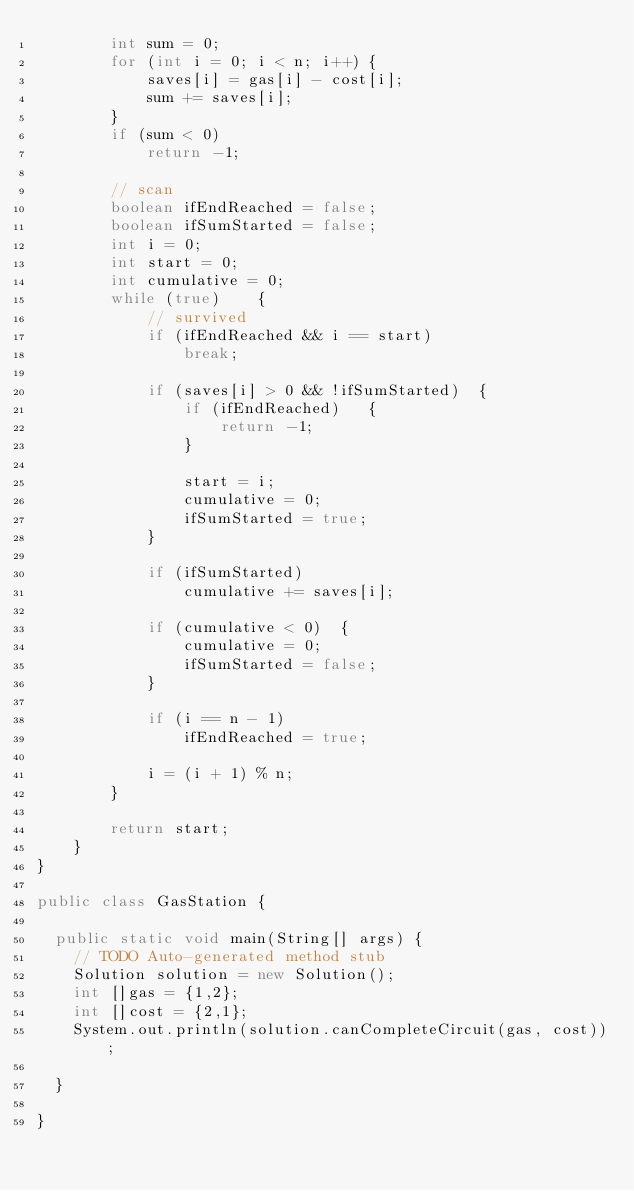<code> <loc_0><loc_0><loc_500><loc_500><_Java_>        int sum = 0;
        for (int i = 0; i < n; i++) {
            saves[i] = gas[i] - cost[i];
            sum += saves[i];
        }
        if (sum < 0)
            return -1;

        // scan
        boolean ifEndReached = false;
        boolean ifSumStarted = false;
        int i = 0;
        int start = 0;
        int cumulative = 0;
        while (true)    {
            // survived
            if (ifEndReached && i == start)
                break;
            
            if (saves[i] > 0 && !ifSumStarted)  {
                if (ifEndReached)   {
                    return -1;
                }
                
                start = i;    
                cumulative = 0;
                ifSumStarted = true;
            }
            
            if (ifSumStarted)
                cumulative += saves[i];

            if (cumulative < 0)  {
                cumulative = 0;
                ifSumStarted = false;                
            }
                
            if (i == n - 1)
                ifEndReached = true;
                
            i = (i + 1) % n;
        }
        
        return start;
    }
}

public class GasStation {

	public static void main(String[] args) {
		// TODO Auto-generated method stub
		Solution solution = new Solution();
		int []gas = {1,2};
		int []cost = {2,1};
		System.out.println(solution.canCompleteCircuit(gas, cost));

	}

}
</code> 